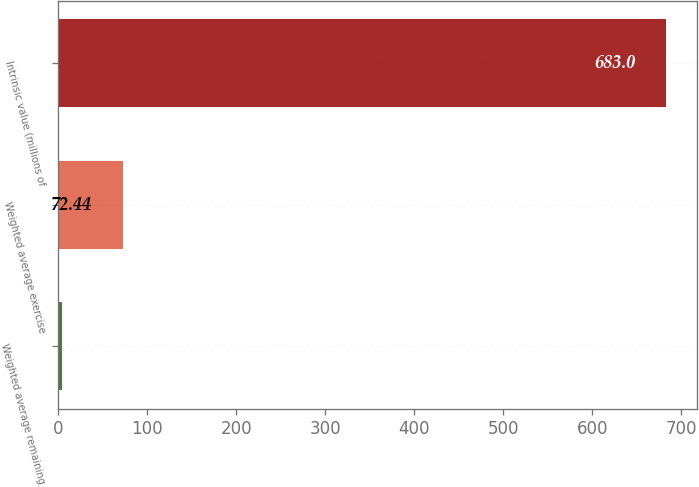Convert chart. <chart><loc_0><loc_0><loc_500><loc_500><bar_chart><fcel>Weighted average remaining<fcel>Weighted average exercise<fcel>Intrinsic value (millions of<nl><fcel>4.6<fcel>72.44<fcel>683<nl></chart> 